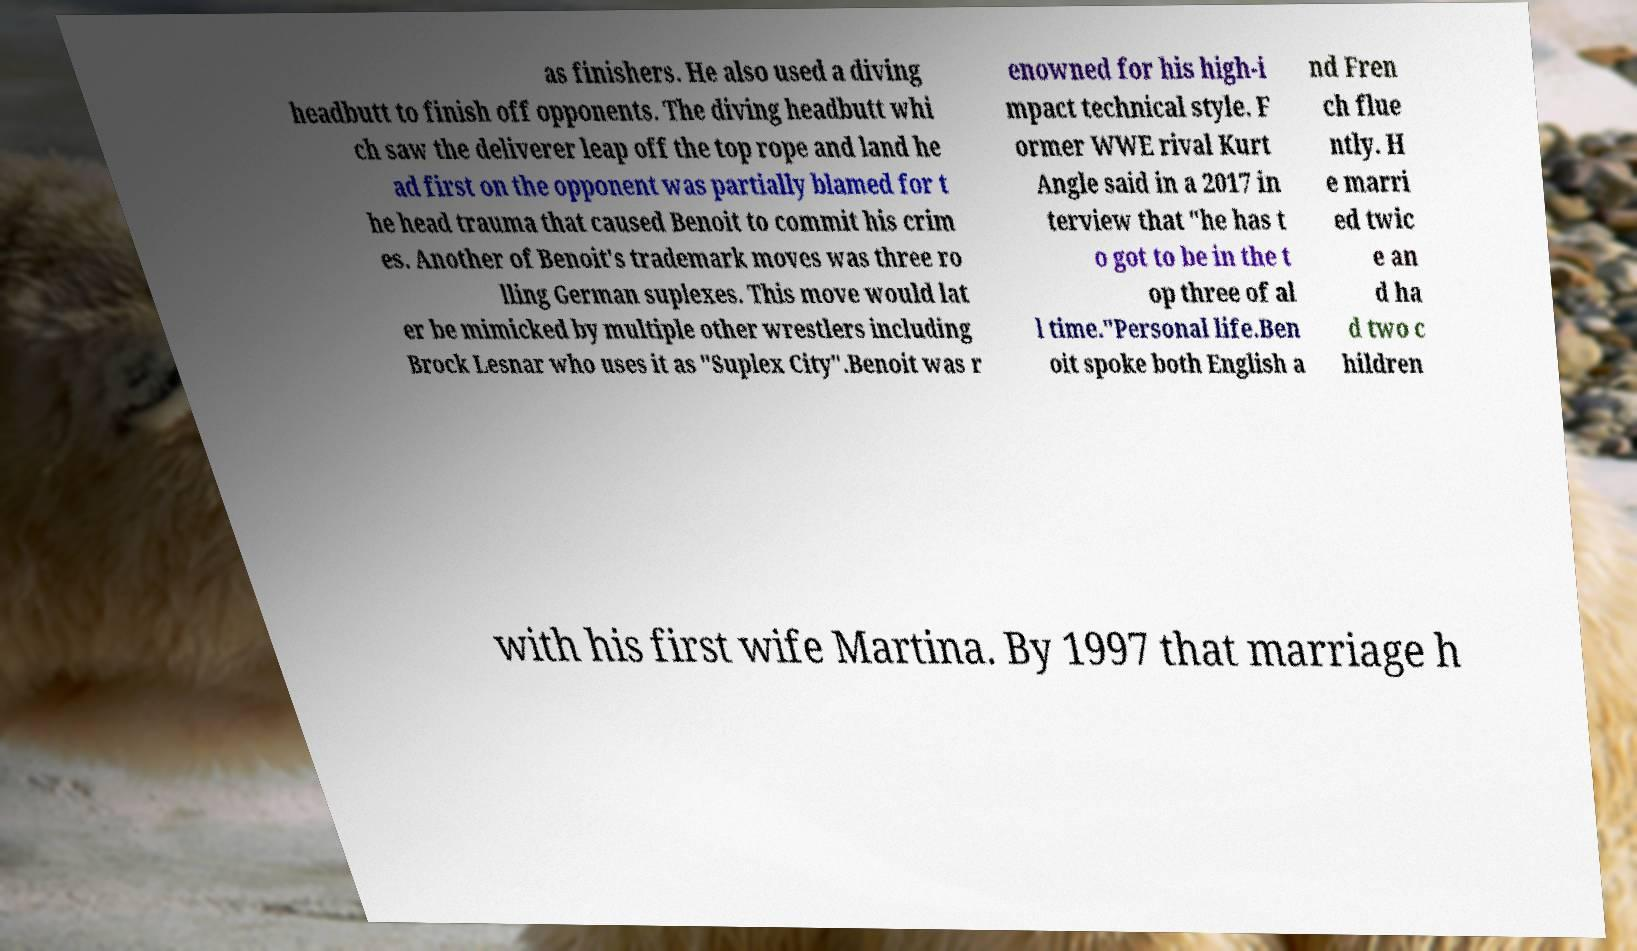For documentation purposes, I need the text within this image transcribed. Could you provide that? as finishers. He also used a diving headbutt to finish off opponents. The diving headbutt whi ch saw the deliverer leap off the top rope and land he ad first on the opponent was partially blamed for t he head trauma that caused Benoit to commit his crim es. Another of Benoit's trademark moves was three ro lling German suplexes. This move would lat er be mimicked by multiple other wrestlers including Brock Lesnar who uses it as "Suplex City".Benoit was r enowned for his high-i mpact technical style. F ormer WWE rival Kurt Angle said in a 2017 in terview that "he has t o got to be in the t op three of al l time."Personal life.Ben oit spoke both English a nd Fren ch flue ntly. H e marri ed twic e an d ha d two c hildren with his first wife Martina. By 1997 that marriage h 